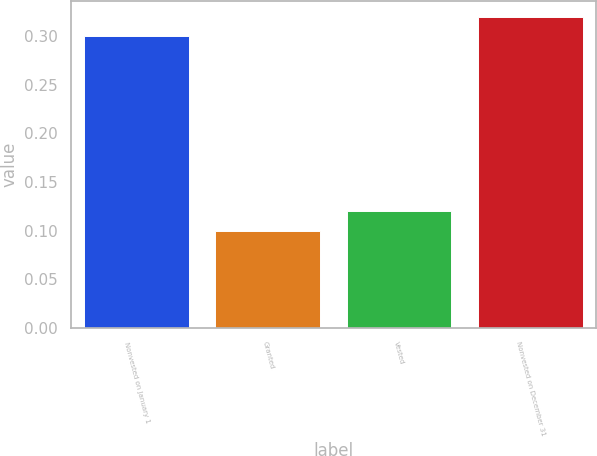Convert chart to OTSL. <chart><loc_0><loc_0><loc_500><loc_500><bar_chart><fcel>Nonvested on January 1<fcel>Granted<fcel>Vested<fcel>Nonvested on December 31<nl><fcel>0.3<fcel>0.1<fcel>0.12<fcel>0.32<nl></chart> 